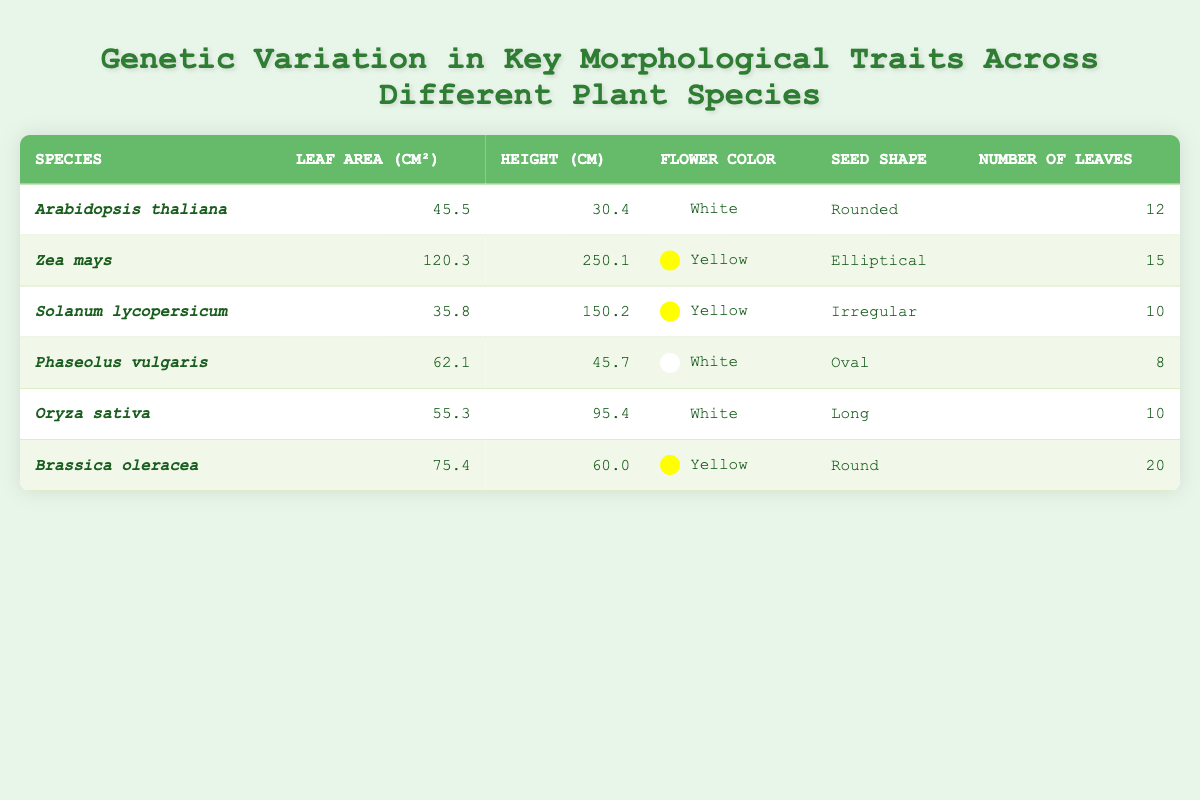What is the leaf area of Zea mays? The table indicates that the leaf area of Zea mays is listed directly under the "Leaf Area (cm²)" column for this species. It is 120.3 cm².
Answer: 120.3 cm² Which plant species has the highest number of leaves? To find the plant species with the highest number of leaves, we can look at the "Number of Leaves" column. The values are: 12 (Arabidopsis thaliana), 15 (Zea mays), 10 (Solanum lycopersicum), 8 (Phaseolus vulgaris), 10 (Oryza sativa), and 20 (Brassica oleracea). The highest number is 20, which corresponds to Brassica oleracea.
Answer: Brassica oleracea What is the average height of the plants listed in the table? To find the average height, we first identify the heights: 30.4 (Arabidopsis thaliana), 250.1 (Zea mays), 150.2 (Solanum lycopersicum), 45.7 (Phaseolus vulgaris), 95.4 (Oryza sativa), and 60.0 (Brassica oleracea). We sum these heights: 30.4 + 250.1 + 150.2 + 45.7 + 95.4 + 60.0 = 632.0 cm. Then, we divide by the number of species, which is 6: 632.0 / 6 = 105.33.
Answer: 105.33 cm Is the seed shape of Solanum lycopersicum irregular? Checking the "Seed Shape" column for Solanum lycopersicum, we see it is indeed listed as "Irregular." Therefore, the statement is true.
Answer: Yes Which plant species has the largest leaf area compared to its height, and what is the ratio? To find the species with the largest leaf area-to-height ratio, we must first calculate the ratio for each: Arabidopsis thaliana: 45.5 / 30.4 = 1.50, Zea mays: 120.3 / 250.1 = 0.48, Solanum lycopersicum: 35.8 / 150.2 = 0.24, Phaseolus vulgaris: 62.1 / 45.7 = 1.36, Oryza sativa: 55.3 / 95.4 = 0.58, Brassica oleracea: 75.4 / 60.0 = 1.26. The largest ratio is 1.50 for Arabidopsis thaliana.
Answer: Arabidopsis thaliana with a ratio of 1.50 